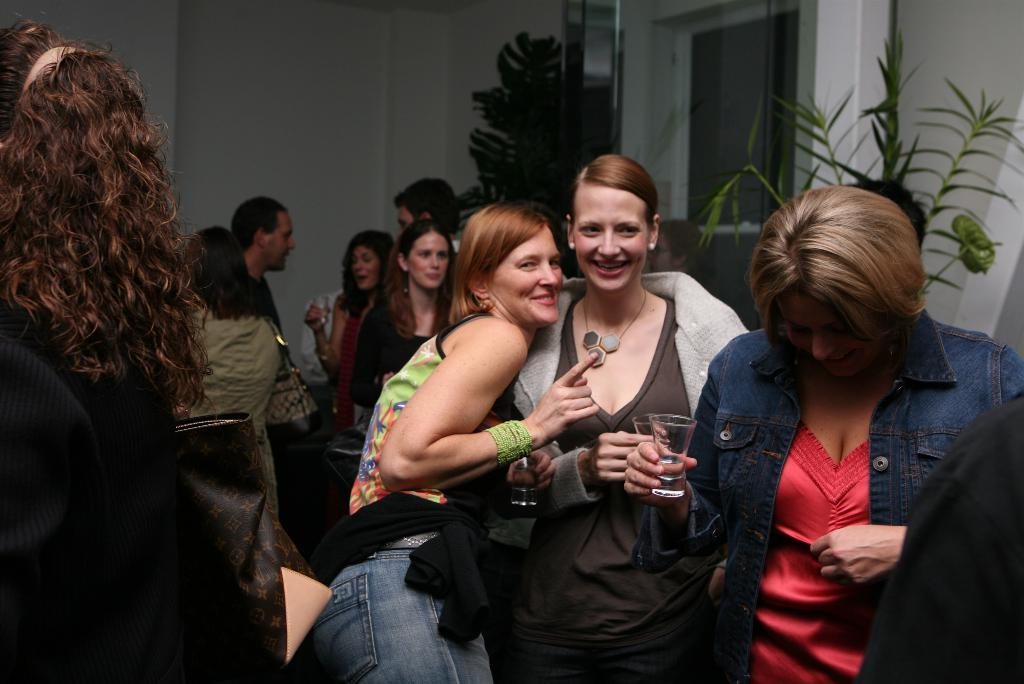What is one of the main features in the image? There is a wall in the image. What else can be seen in the image besides the wall? There are plants and people standing in the image. What are the people holding in their hands? The people are holding glasses in the image. What type of insurance policy is being discussed by the people in the image? There is no indication in the image that the people are discussing any type of insurance policy. 